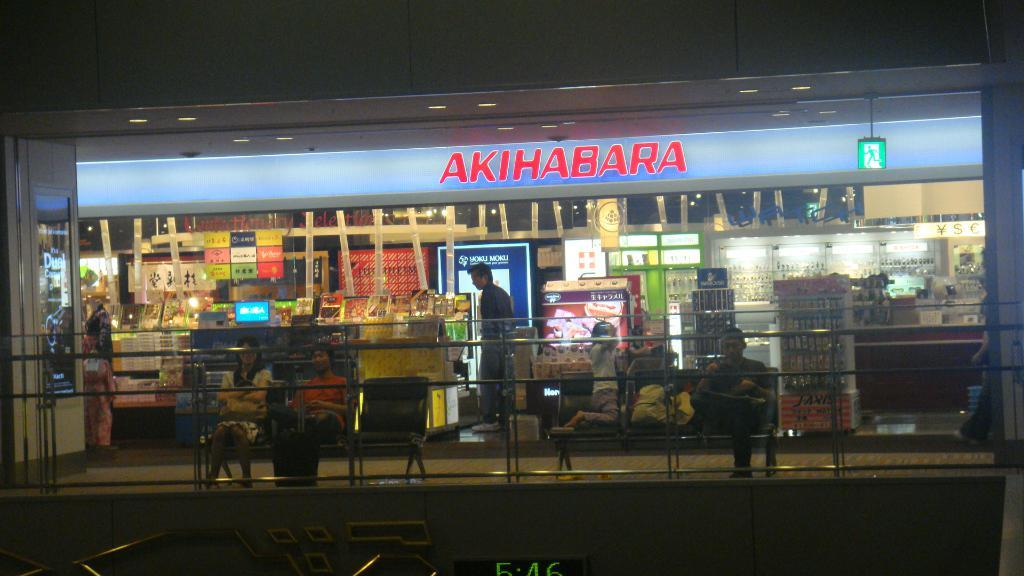<image>
Relay a brief, clear account of the picture shown. A store named AKIHABARA is pictured at night time. 